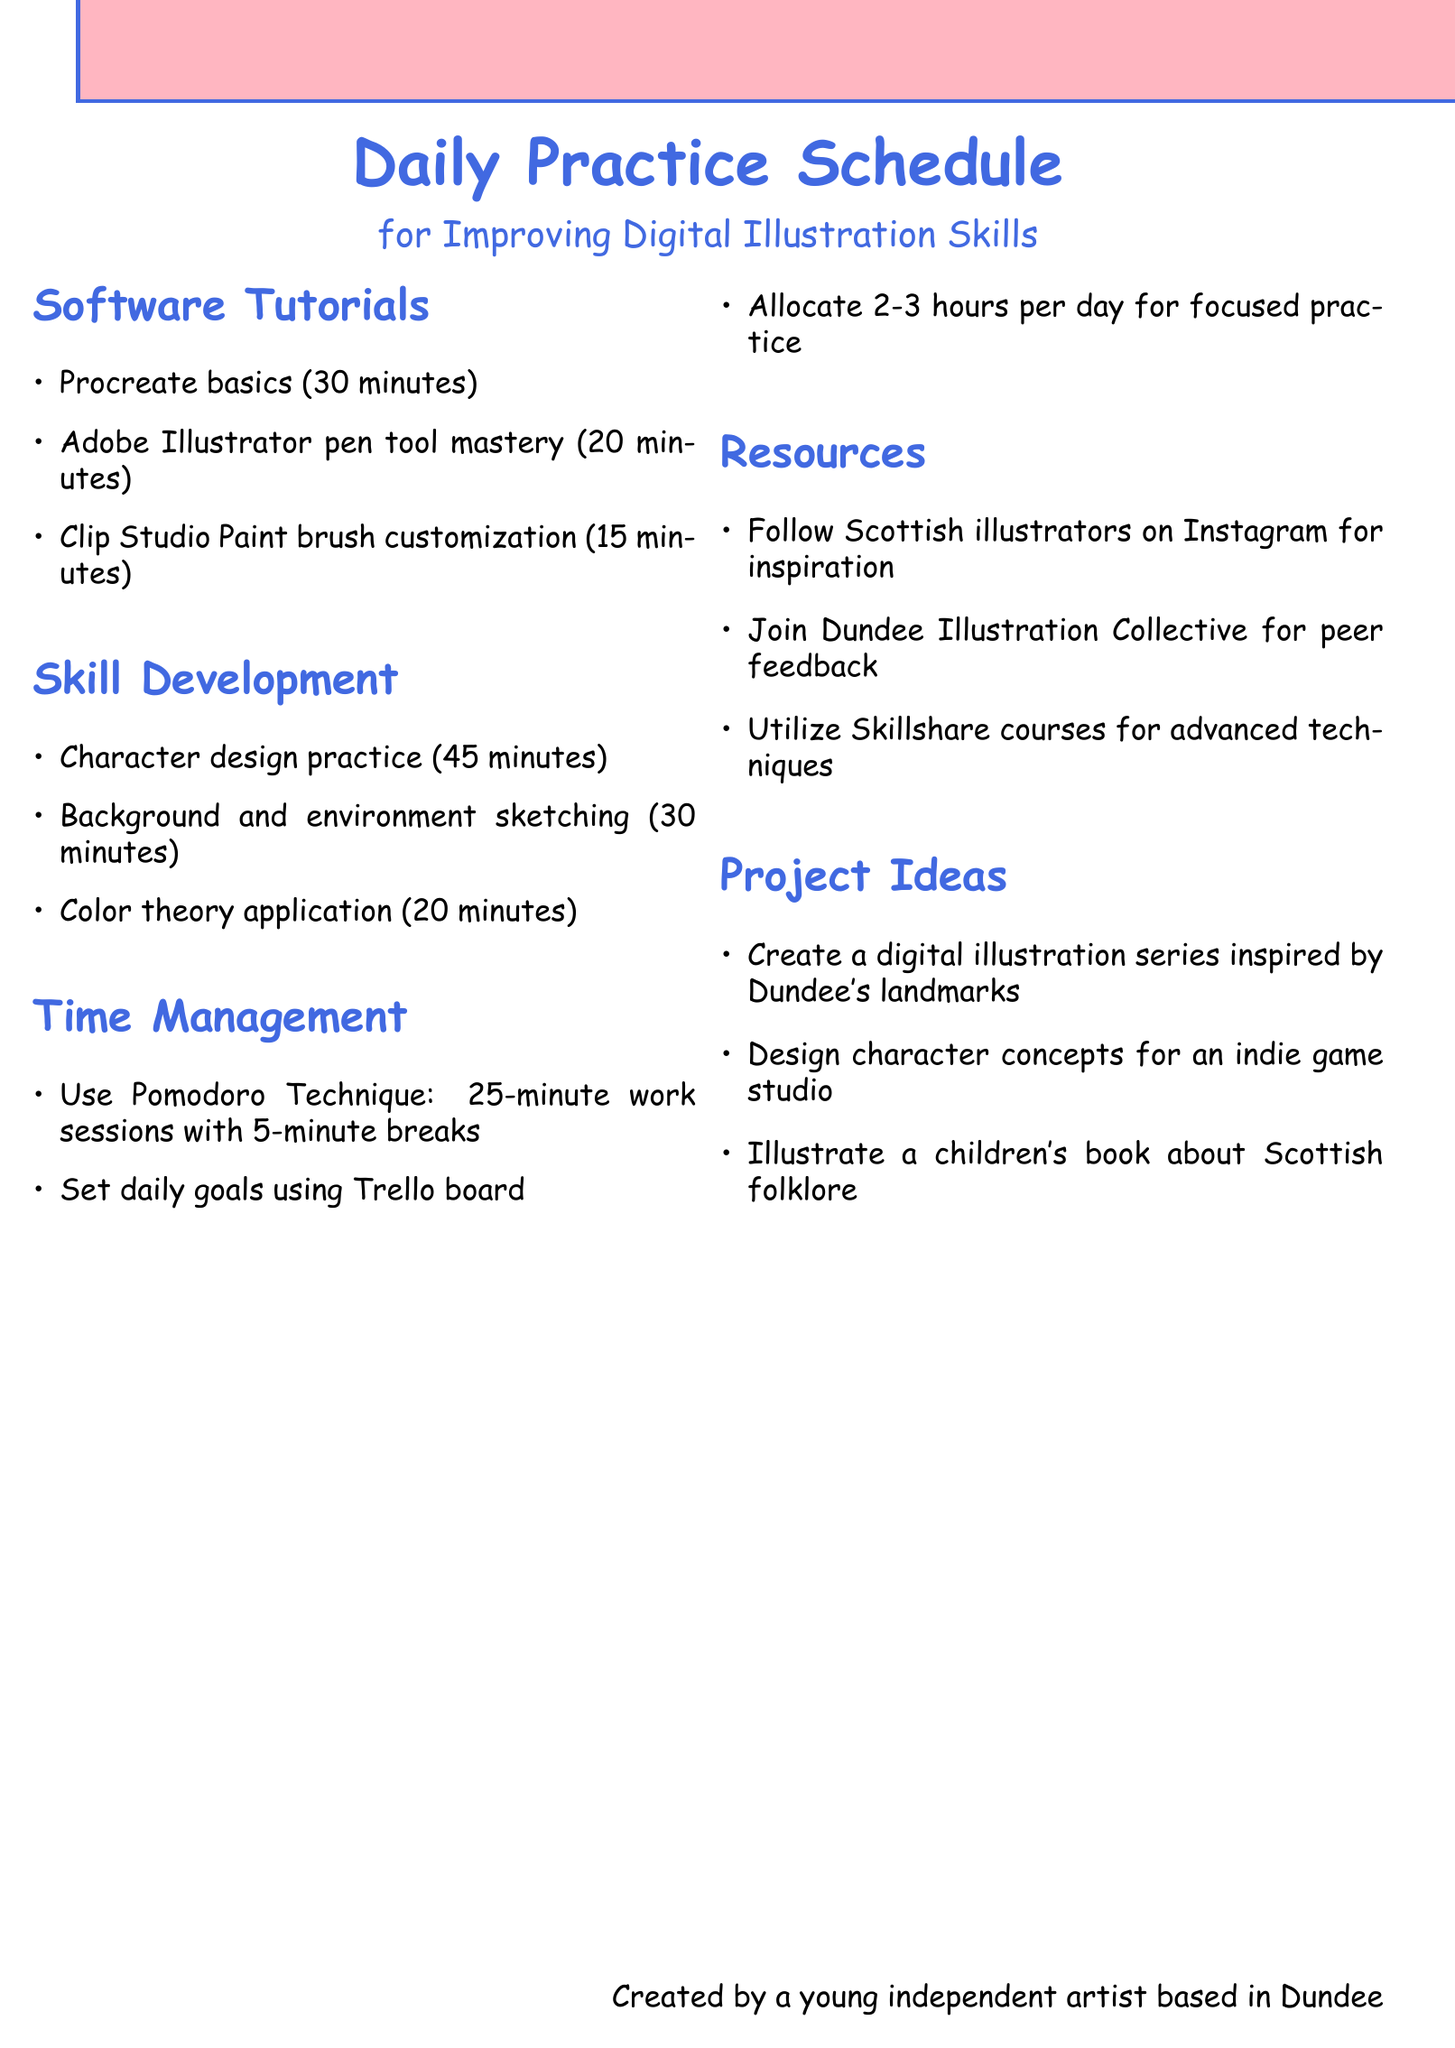What are the three software tutorials mentioned? The three software tutorials listed are Procreate basics, Adobe Illustrator pen tool mastery, and Clip Studio Paint brush customization.
Answer: Procreate basics, Adobe Illustrator pen tool mastery, Clip Studio Paint brush customization How long is the character design practice? The document states that the character design practice takes 45 minutes.
Answer: 45 minutes What technique is recommended for time management? The document suggests using the Pomodoro Technique for managing time.
Answer: Pomodoro Technique Which social media platform should artists follow for inspiration? The document advises to follow Scottish illustrators on Instagram for inspiration.
Answer: Instagram How many project ideas are listed in the document? There are three project ideas provided in the document for digital illustration projects.
Answer: 3 What is the recommended daily practice duration? The document indicates that 2-3 hours should be allocated each day for focused practice.
Answer: 2-3 hours What should be utilized for advanced techniques? The document recommends utilizing Skillshare courses to learn advanced techniques.
Answer: Skillshare courses Which local collective is mentioned for peer feedback? The Dundee Illustration Collective is mentioned as a resource for receiving peer feedback.
Answer: Dundee Illustration Collective What is the focus of the children's book mentioned in the project ideas? The children's book project idea focuses on Scottish folklore.
Answer: Scottish folklore 